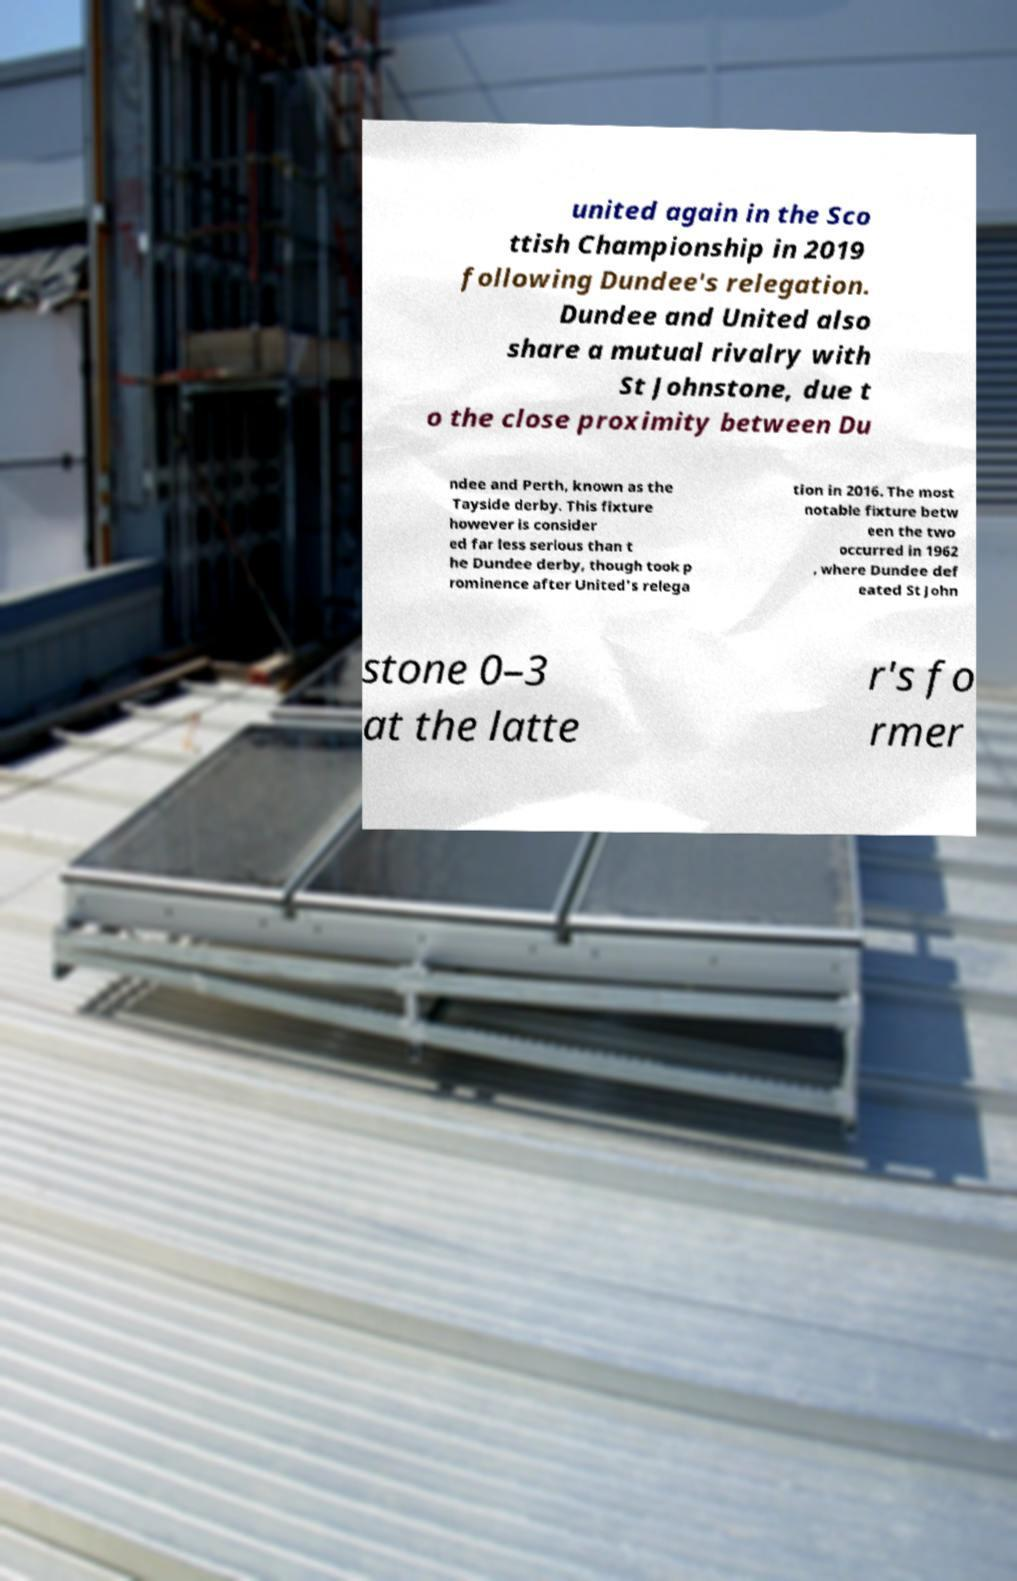Please read and relay the text visible in this image. What does it say? united again in the Sco ttish Championship in 2019 following Dundee's relegation. Dundee and United also share a mutual rivalry with St Johnstone, due t o the close proximity between Du ndee and Perth, known as the Tayside derby. This fixture however is consider ed far less serious than t he Dundee derby, though took p rominence after United's relega tion in 2016. The most notable fixture betw een the two occurred in 1962 , where Dundee def eated St John stone 0–3 at the latte r's fo rmer 